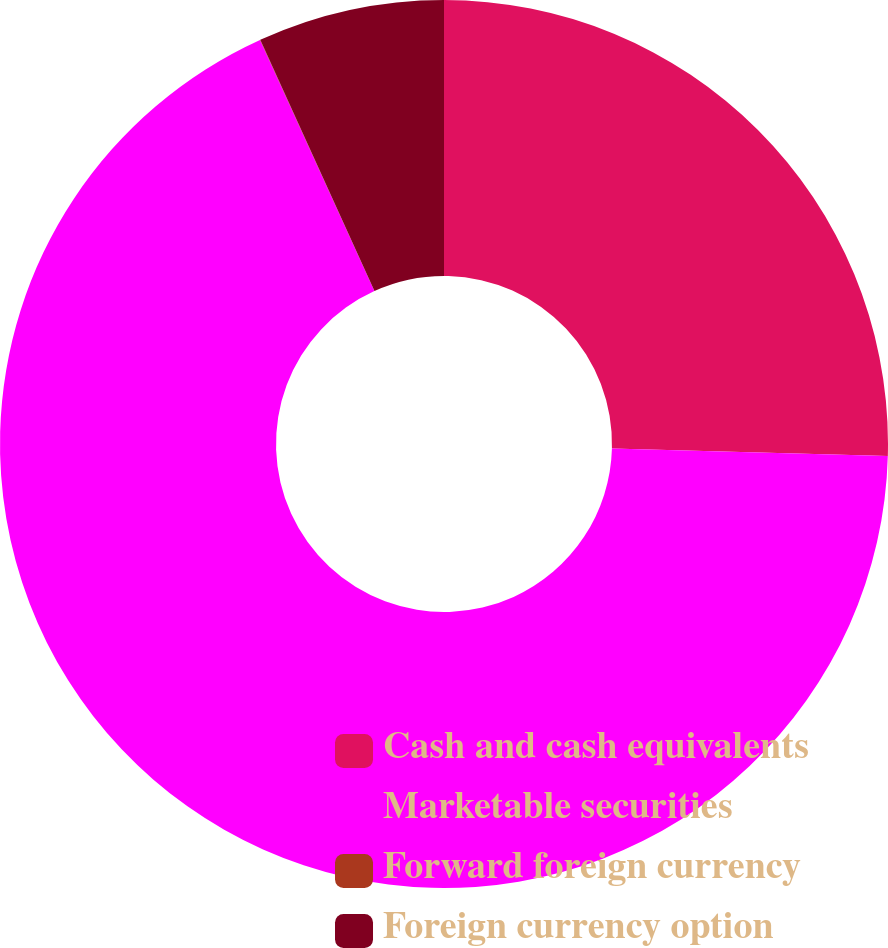Convert chart. <chart><loc_0><loc_0><loc_500><loc_500><pie_chart><fcel>Cash and cash equivalents<fcel>Marketable securities<fcel>Forward foreign currency<fcel>Foreign currency option<nl><fcel>25.43%<fcel>67.77%<fcel>0.01%<fcel>6.79%<nl></chart> 